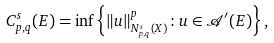<formula> <loc_0><loc_0><loc_500><loc_500>C _ { p , q } ^ { s } ( E ) = \inf \left \{ \| u \| _ { N _ { p , q } ^ { s } ( X ) } ^ { p } \colon u \in \mathcal { A } ^ { \prime } ( E ) \right \} ,</formula> 